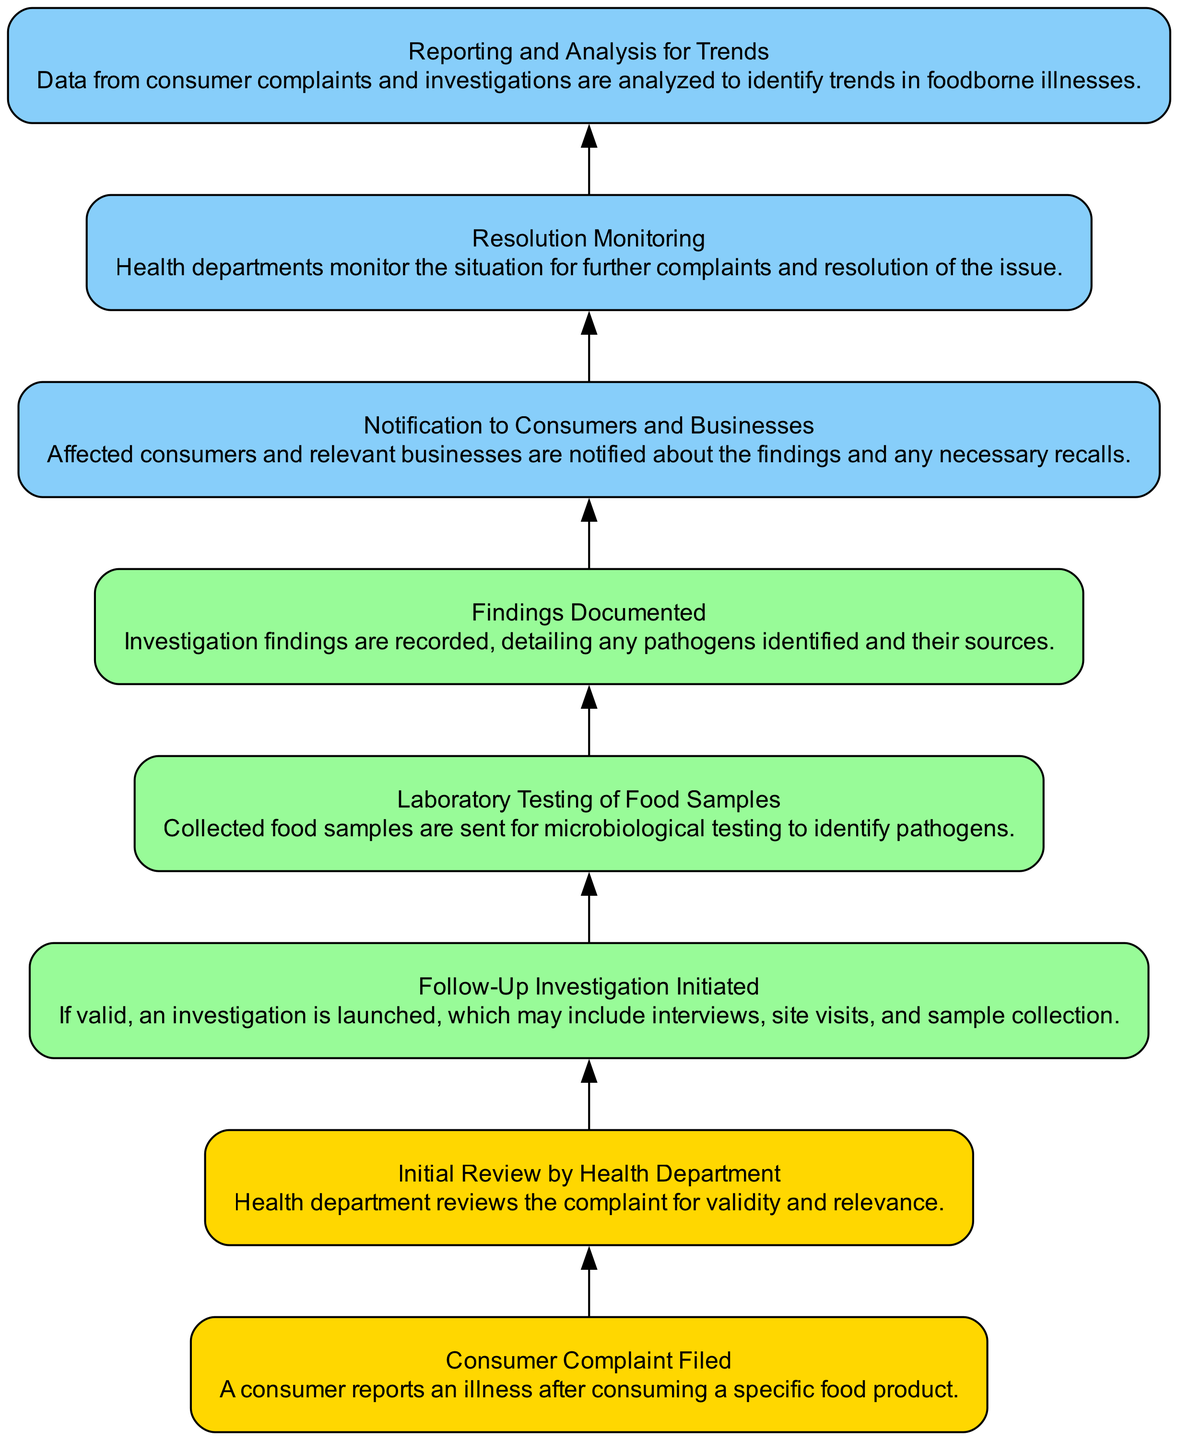What is the first step in the flowchart? The first step in the flowchart, as represented by node 1, is "Consumer Complaint Filed," indicating that a consumer reports an illness.
Answer: Consumer Complaint Filed How many total nodes are in the flowchart? The flowchart consists of 8 distinct nodes, each representing a stage in the process of tracking foodborne illness complaints.
Answer: 8 What is documented after laboratory testing? Following the laboratory testing, the next step is to document the "Findings Documented," which is essential for recording the investigation outcomes.
Answer: Findings Documented Which node comes immediately after "Initial Review by Health Department"? After the "Initial Review by Health Department," the flowchart proceeds to "Follow-Up Investigation Initiated," indicating that if the complaint is deemed valid, further investigation will occur.
Answer: Follow-Up Investigation Initiated Describe the color coding in the flowchart for the resolution monitoring steps. The final stages of the flowchart, which include "Notification to Consumers and Businesses," "Resolution Monitoring," and "Reporting and Analysis for Trends," are color-coded with light sky blue, indicating these are late-stage processes.
Answer: Light sky blue What action occurs right before the "Reporting and Analysis for Trends" step? Before the "Reporting and Analysis for Trends" step occurs, there is a "Resolution Monitoring" phase where health departments keep track of the situation for further complaints and resolutions.
Answer: Resolution Monitoring Which node is responsible for notifying affected parties about findings? The "Notification to Consumers and Businesses" node is responsible for informing consumers and businesses about any findings from the investigation.
Answer: Notification to Consumers and Businesses How are the nodes connected to each other in terms of flow? The flow of the nodes follows a downward progression where each step leads to the next, indicating a sequential process that starts from the consumer complaint being filed down to the reporting and analysis of trends.
Answer: Sequential downward progression What is the last node that involves active investigation? The last node related to active investigation is "Laboratory Testing of Food Samples," as this stage involves analyzing collected samples to identify pathogens.
Answer: Laboratory Testing of Food Samples 